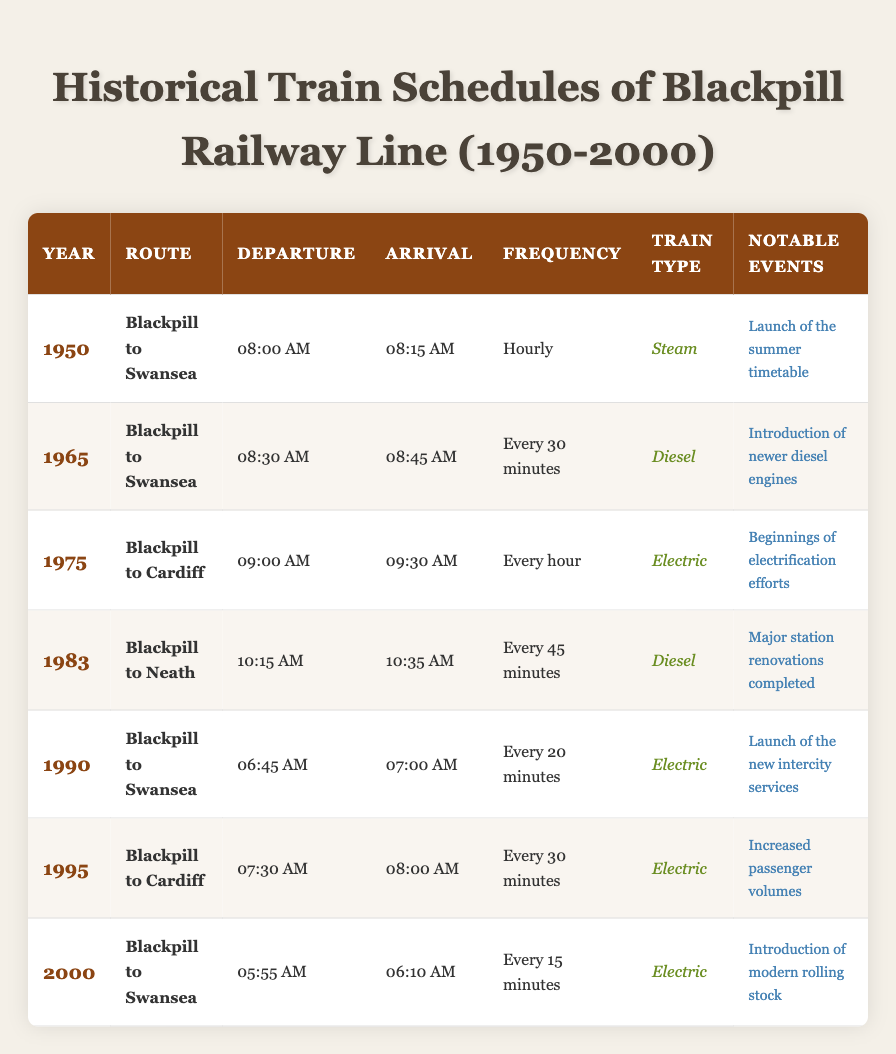What was the departure time for the train from Blackpill to Swansea in 1950? The table indicates that the departure time for the Blackpill to Swansea route in 1950 was listed as 08:00 AM.
Answer: 08:00 AM Which train type was used for the route from Blackpill to Cardiff in 1975? From the table, the train type listed for the Blackpill to Cardiff route in 1975 is Electric.
Answer: Electric In what year did the frequency of the trains from Blackpill to Swansea change to every 20 minutes? The table shows that the frequency for the Blackpill to Swansea route changed to every 20 minutes in 1990.
Answer: 1990 What was the notable event associated with the introduction of newer diesel engines? According to the table, the introduction of newer diesel engines occurred in 1965 as a notable event.
Answer: Introduction of newer diesel engines What was the frequency of trains from Blackpill to Neath in 1983? The frequency of trains for the Blackpill to Neath route in 1983 was every 45 minutes as stated in the table.
Answer: Every 45 minutes How many years were there between the launch of the summer timetable and the introduction of electrification efforts? The launch of the summer timetable was in 1950, and the introduction of electrification efforts was in 1975. The difference is 1975 - 1950 = 25 years.
Answer: 25 years Was there a notable event related to increased passenger volumes before the year 2000? The table lists that increased passenger volumes occurred in 1995, and this is indeed before the year 2000, thus the statement is true.
Answer: Yes What was the earliest departure time recorded for any route on the table? The earliest departure time is 05:55 AM for the route from Blackpill to Swansea in the year 2000.
Answer: 05:55 AM What type of train operated on the Blackpill to Swansea route in 1990, and how often did it run? In 1990, the table states that the Blackpill to Swansea route operated Diesel trains every 20 minutes.
Answer: Electric, every 20 minutes In which year did the frequency shift to every 15 minutes for the Blackpill to Swansea route? The shift to every 15 minutes occurred in 2000, as indicated in the table.
Answer: 2000 How many different routes were documented in the table, and what are they? There are three different routes documented: Blackpill to Swansea, Blackpill to Cardiff, and Blackpill to Neath. The count of unique routes is 3.
Answer: 3 routes Which decade saw the major station renovations completed? The major station renovations were completed in 1983, which is part of the 1980s decade.
Answer: 1983 What was the average frequency of the trains listed from 1950 to 2000? To find the average frequency, convert the frequency measures to numerical values: Hourly = 60 minutes, Every 30 minutes = 30, Every hour = 60, Every 45 minutes = 45, Every 20 minutes = 20, Every 30 minutes = 30, Every 15 minutes = 15. Calculate the average: (60+30+60+45+20+30+15)/7 = 37.14 minutes.
Answer: 37.14 minutes 